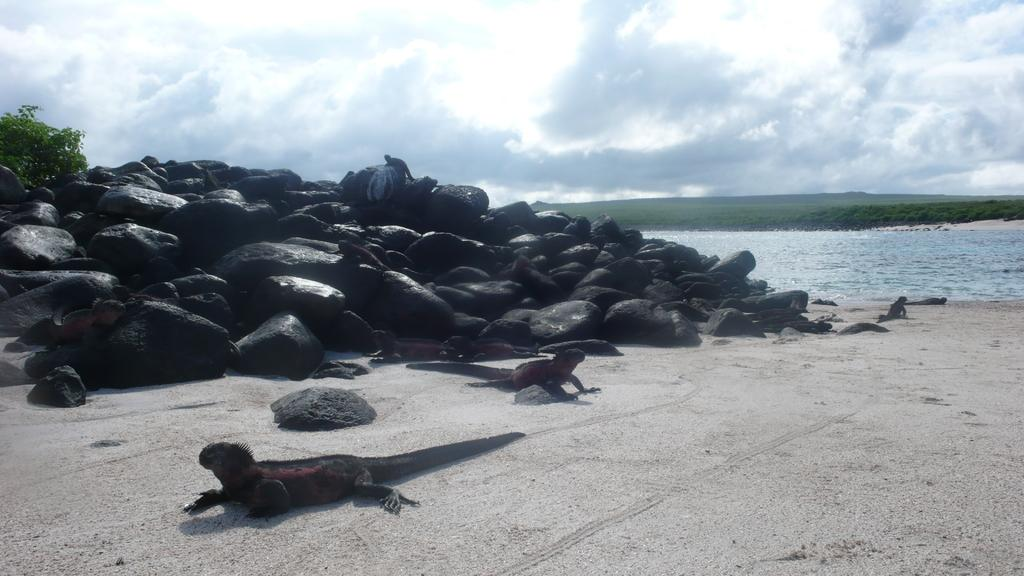What type of natural elements can be seen in the image? There are stones, sand, and grass visible in the image. What type of animals are present in the image? There are reptiles in the image. What can be seen in the background of the image? There is water, a plant, and a cloudy sky visible in the background of the image. What type of cannon is being used by the kittens in the image? There are no kittens or cannons present in the image. What appliance is being used by the reptiles in the image? There are no appliances present in the image; the reptiles are interacting with the natural elements in the image. 